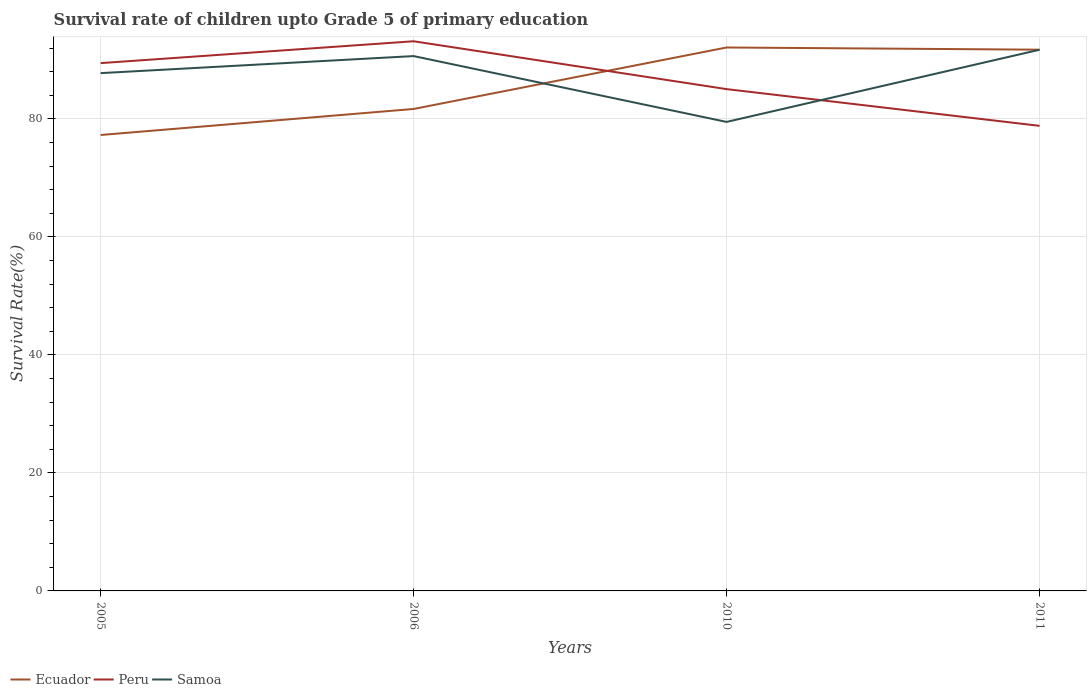Across all years, what is the maximum survival rate of children in Ecuador?
Offer a very short reply. 77.29. In which year was the survival rate of children in Peru maximum?
Provide a succinct answer. 2011. What is the total survival rate of children in Peru in the graph?
Offer a terse response. 10.63. What is the difference between the highest and the second highest survival rate of children in Ecuador?
Your response must be concise. 14.83. Is the survival rate of children in Samoa strictly greater than the survival rate of children in Peru over the years?
Offer a very short reply. No. How many years are there in the graph?
Your answer should be very brief. 4. Where does the legend appear in the graph?
Keep it short and to the point. Bottom left. How many legend labels are there?
Provide a short and direct response. 3. What is the title of the graph?
Your response must be concise. Survival rate of children upto Grade 5 of primary education. Does "Sub-Saharan Africa (all income levels)" appear as one of the legend labels in the graph?
Offer a very short reply. No. What is the label or title of the X-axis?
Give a very brief answer. Years. What is the label or title of the Y-axis?
Make the answer very short. Survival Rate(%). What is the Survival Rate(%) in Ecuador in 2005?
Keep it short and to the point. 77.29. What is the Survival Rate(%) of Peru in 2005?
Your answer should be compact. 89.47. What is the Survival Rate(%) in Samoa in 2005?
Make the answer very short. 87.78. What is the Survival Rate(%) of Ecuador in 2006?
Offer a terse response. 81.7. What is the Survival Rate(%) of Peru in 2006?
Your response must be concise. 93.18. What is the Survival Rate(%) in Samoa in 2006?
Keep it short and to the point. 90.66. What is the Survival Rate(%) of Ecuador in 2010?
Your response must be concise. 92.12. What is the Survival Rate(%) of Peru in 2010?
Provide a succinct answer. 85.06. What is the Survival Rate(%) of Samoa in 2010?
Your response must be concise. 79.5. What is the Survival Rate(%) of Ecuador in 2011?
Keep it short and to the point. 91.75. What is the Survival Rate(%) of Peru in 2011?
Your answer should be compact. 78.84. What is the Survival Rate(%) in Samoa in 2011?
Keep it short and to the point. 91.74. Across all years, what is the maximum Survival Rate(%) of Ecuador?
Make the answer very short. 92.12. Across all years, what is the maximum Survival Rate(%) in Peru?
Make the answer very short. 93.18. Across all years, what is the maximum Survival Rate(%) in Samoa?
Your answer should be very brief. 91.74. Across all years, what is the minimum Survival Rate(%) in Ecuador?
Offer a terse response. 77.29. Across all years, what is the minimum Survival Rate(%) of Peru?
Your answer should be very brief. 78.84. Across all years, what is the minimum Survival Rate(%) in Samoa?
Ensure brevity in your answer.  79.5. What is the total Survival Rate(%) in Ecuador in the graph?
Your answer should be compact. 342.86. What is the total Survival Rate(%) in Peru in the graph?
Give a very brief answer. 346.55. What is the total Survival Rate(%) of Samoa in the graph?
Keep it short and to the point. 349.68. What is the difference between the Survival Rate(%) in Ecuador in 2005 and that in 2006?
Provide a short and direct response. -4.41. What is the difference between the Survival Rate(%) of Peru in 2005 and that in 2006?
Your response must be concise. -3.71. What is the difference between the Survival Rate(%) in Samoa in 2005 and that in 2006?
Ensure brevity in your answer.  -2.89. What is the difference between the Survival Rate(%) of Ecuador in 2005 and that in 2010?
Provide a succinct answer. -14.83. What is the difference between the Survival Rate(%) in Peru in 2005 and that in 2010?
Provide a short and direct response. 4.41. What is the difference between the Survival Rate(%) in Samoa in 2005 and that in 2010?
Offer a terse response. 8.27. What is the difference between the Survival Rate(%) in Ecuador in 2005 and that in 2011?
Provide a succinct answer. -14.46. What is the difference between the Survival Rate(%) of Peru in 2005 and that in 2011?
Ensure brevity in your answer.  10.63. What is the difference between the Survival Rate(%) of Samoa in 2005 and that in 2011?
Provide a short and direct response. -3.96. What is the difference between the Survival Rate(%) of Ecuador in 2006 and that in 2010?
Your response must be concise. -10.42. What is the difference between the Survival Rate(%) of Peru in 2006 and that in 2010?
Ensure brevity in your answer.  8.11. What is the difference between the Survival Rate(%) of Samoa in 2006 and that in 2010?
Make the answer very short. 11.16. What is the difference between the Survival Rate(%) of Ecuador in 2006 and that in 2011?
Give a very brief answer. -10.05. What is the difference between the Survival Rate(%) of Peru in 2006 and that in 2011?
Keep it short and to the point. 14.34. What is the difference between the Survival Rate(%) of Samoa in 2006 and that in 2011?
Provide a short and direct response. -1.07. What is the difference between the Survival Rate(%) of Ecuador in 2010 and that in 2011?
Your answer should be compact. 0.37. What is the difference between the Survival Rate(%) of Peru in 2010 and that in 2011?
Offer a very short reply. 6.22. What is the difference between the Survival Rate(%) in Samoa in 2010 and that in 2011?
Provide a short and direct response. -12.23. What is the difference between the Survival Rate(%) of Ecuador in 2005 and the Survival Rate(%) of Peru in 2006?
Your answer should be very brief. -15.89. What is the difference between the Survival Rate(%) in Ecuador in 2005 and the Survival Rate(%) in Samoa in 2006?
Ensure brevity in your answer.  -13.38. What is the difference between the Survival Rate(%) in Peru in 2005 and the Survival Rate(%) in Samoa in 2006?
Keep it short and to the point. -1.19. What is the difference between the Survival Rate(%) of Ecuador in 2005 and the Survival Rate(%) of Peru in 2010?
Provide a short and direct response. -7.77. What is the difference between the Survival Rate(%) in Ecuador in 2005 and the Survival Rate(%) in Samoa in 2010?
Provide a succinct answer. -2.22. What is the difference between the Survival Rate(%) in Peru in 2005 and the Survival Rate(%) in Samoa in 2010?
Ensure brevity in your answer.  9.97. What is the difference between the Survival Rate(%) in Ecuador in 2005 and the Survival Rate(%) in Peru in 2011?
Provide a succinct answer. -1.55. What is the difference between the Survival Rate(%) in Ecuador in 2005 and the Survival Rate(%) in Samoa in 2011?
Provide a short and direct response. -14.45. What is the difference between the Survival Rate(%) in Peru in 2005 and the Survival Rate(%) in Samoa in 2011?
Your answer should be compact. -2.27. What is the difference between the Survival Rate(%) of Ecuador in 2006 and the Survival Rate(%) of Peru in 2010?
Offer a terse response. -3.36. What is the difference between the Survival Rate(%) in Ecuador in 2006 and the Survival Rate(%) in Samoa in 2010?
Provide a succinct answer. 2.2. What is the difference between the Survival Rate(%) of Peru in 2006 and the Survival Rate(%) of Samoa in 2010?
Offer a very short reply. 13.67. What is the difference between the Survival Rate(%) of Ecuador in 2006 and the Survival Rate(%) of Peru in 2011?
Give a very brief answer. 2.86. What is the difference between the Survival Rate(%) of Ecuador in 2006 and the Survival Rate(%) of Samoa in 2011?
Offer a terse response. -10.04. What is the difference between the Survival Rate(%) of Peru in 2006 and the Survival Rate(%) of Samoa in 2011?
Ensure brevity in your answer.  1.44. What is the difference between the Survival Rate(%) of Ecuador in 2010 and the Survival Rate(%) of Peru in 2011?
Offer a terse response. 13.28. What is the difference between the Survival Rate(%) of Ecuador in 2010 and the Survival Rate(%) of Samoa in 2011?
Provide a succinct answer. 0.38. What is the difference between the Survival Rate(%) of Peru in 2010 and the Survival Rate(%) of Samoa in 2011?
Your answer should be very brief. -6.68. What is the average Survival Rate(%) of Ecuador per year?
Offer a terse response. 85.72. What is the average Survival Rate(%) of Peru per year?
Offer a very short reply. 86.64. What is the average Survival Rate(%) in Samoa per year?
Your answer should be very brief. 87.42. In the year 2005, what is the difference between the Survival Rate(%) in Ecuador and Survival Rate(%) in Peru?
Provide a succinct answer. -12.18. In the year 2005, what is the difference between the Survival Rate(%) in Ecuador and Survival Rate(%) in Samoa?
Give a very brief answer. -10.49. In the year 2005, what is the difference between the Survival Rate(%) in Peru and Survival Rate(%) in Samoa?
Make the answer very short. 1.7. In the year 2006, what is the difference between the Survival Rate(%) of Ecuador and Survival Rate(%) of Peru?
Your answer should be compact. -11.48. In the year 2006, what is the difference between the Survival Rate(%) in Ecuador and Survival Rate(%) in Samoa?
Give a very brief answer. -8.96. In the year 2006, what is the difference between the Survival Rate(%) in Peru and Survival Rate(%) in Samoa?
Give a very brief answer. 2.51. In the year 2010, what is the difference between the Survival Rate(%) of Ecuador and Survival Rate(%) of Peru?
Ensure brevity in your answer.  7.06. In the year 2010, what is the difference between the Survival Rate(%) of Ecuador and Survival Rate(%) of Samoa?
Your answer should be compact. 12.62. In the year 2010, what is the difference between the Survival Rate(%) of Peru and Survival Rate(%) of Samoa?
Give a very brief answer. 5.56. In the year 2011, what is the difference between the Survival Rate(%) in Ecuador and Survival Rate(%) in Peru?
Offer a terse response. 12.91. In the year 2011, what is the difference between the Survival Rate(%) of Ecuador and Survival Rate(%) of Samoa?
Offer a terse response. 0.01. In the year 2011, what is the difference between the Survival Rate(%) of Peru and Survival Rate(%) of Samoa?
Keep it short and to the point. -12.9. What is the ratio of the Survival Rate(%) in Ecuador in 2005 to that in 2006?
Offer a terse response. 0.95. What is the ratio of the Survival Rate(%) in Peru in 2005 to that in 2006?
Provide a short and direct response. 0.96. What is the ratio of the Survival Rate(%) in Samoa in 2005 to that in 2006?
Offer a terse response. 0.97. What is the ratio of the Survival Rate(%) in Ecuador in 2005 to that in 2010?
Give a very brief answer. 0.84. What is the ratio of the Survival Rate(%) of Peru in 2005 to that in 2010?
Make the answer very short. 1.05. What is the ratio of the Survival Rate(%) of Samoa in 2005 to that in 2010?
Your response must be concise. 1.1. What is the ratio of the Survival Rate(%) of Ecuador in 2005 to that in 2011?
Ensure brevity in your answer.  0.84. What is the ratio of the Survival Rate(%) in Peru in 2005 to that in 2011?
Give a very brief answer. 1.13. What is the ratio of the Survival Rate(%) of Samoa in 2005 to that in 2011?
Keep it short and to the point. 0.96. What is the ratio of the Survival Rate(%) of Ecuador in 2006 to that in 2010?
Your answer should be compact. 0.89. What is the ratio of the Survival Rate(%) in Peru in 2006 to that in 2010?
Keep it short and to the point. 1.1. What is the ratio of the Survival Rate(%) in Samoa in 2006 to that in 2010?
Your response must be concise. 1.14. What is the ratio of the Survival Rate(%) in Ecuador in 2006 to that in 2011?
Ensure brevity in your answer.  0.89. What is the ratio of the Survival Rate(%) in Peru in 2006 to that in 2011?
Offer a terse response. 1.18. What is the ratio of the Survival Rate(%) in Samoa in 2006 to that in 2011?
Provide a short and direct response. 0.99. What is the ratio of the Survival Rate(%) of Ecuador in 2010 to that in 2011?
Offer a terse response. 1. What is the ratio of the Survival Rate(%) of Peru in 2010 to that in 2011?
Provide a short and direct response. 1.08. What is the ratio of the Survival Rate(%) in Samoa in 2010 to that in 2011?
Your answer should be compact. 0.87. What is the difference between the highest and the second highest Survival Rate(%) in Ecuador?
Your answer should be compact. 0.37. What is the difference between the highest and the second highest Survival Rate(%) in Peru?
Your answer should be very brief. 3.71. What is the difference between the highest and the second highest Survival Rate(%) of Samoa?
Provide a short and direct response. 1.07. What is the difference between the highest and the lowest Survival Rate(%) in Ecuador?
Offer a terse response. 14.83. What is the difference between the highest and the lowest Survival Rate(%) in Peru?
Make the answer very short. 14.34. What is the difference between the highest and the lowest Survival Rate(%) of Samoa?
Keep it short and to the point. 12.23. 